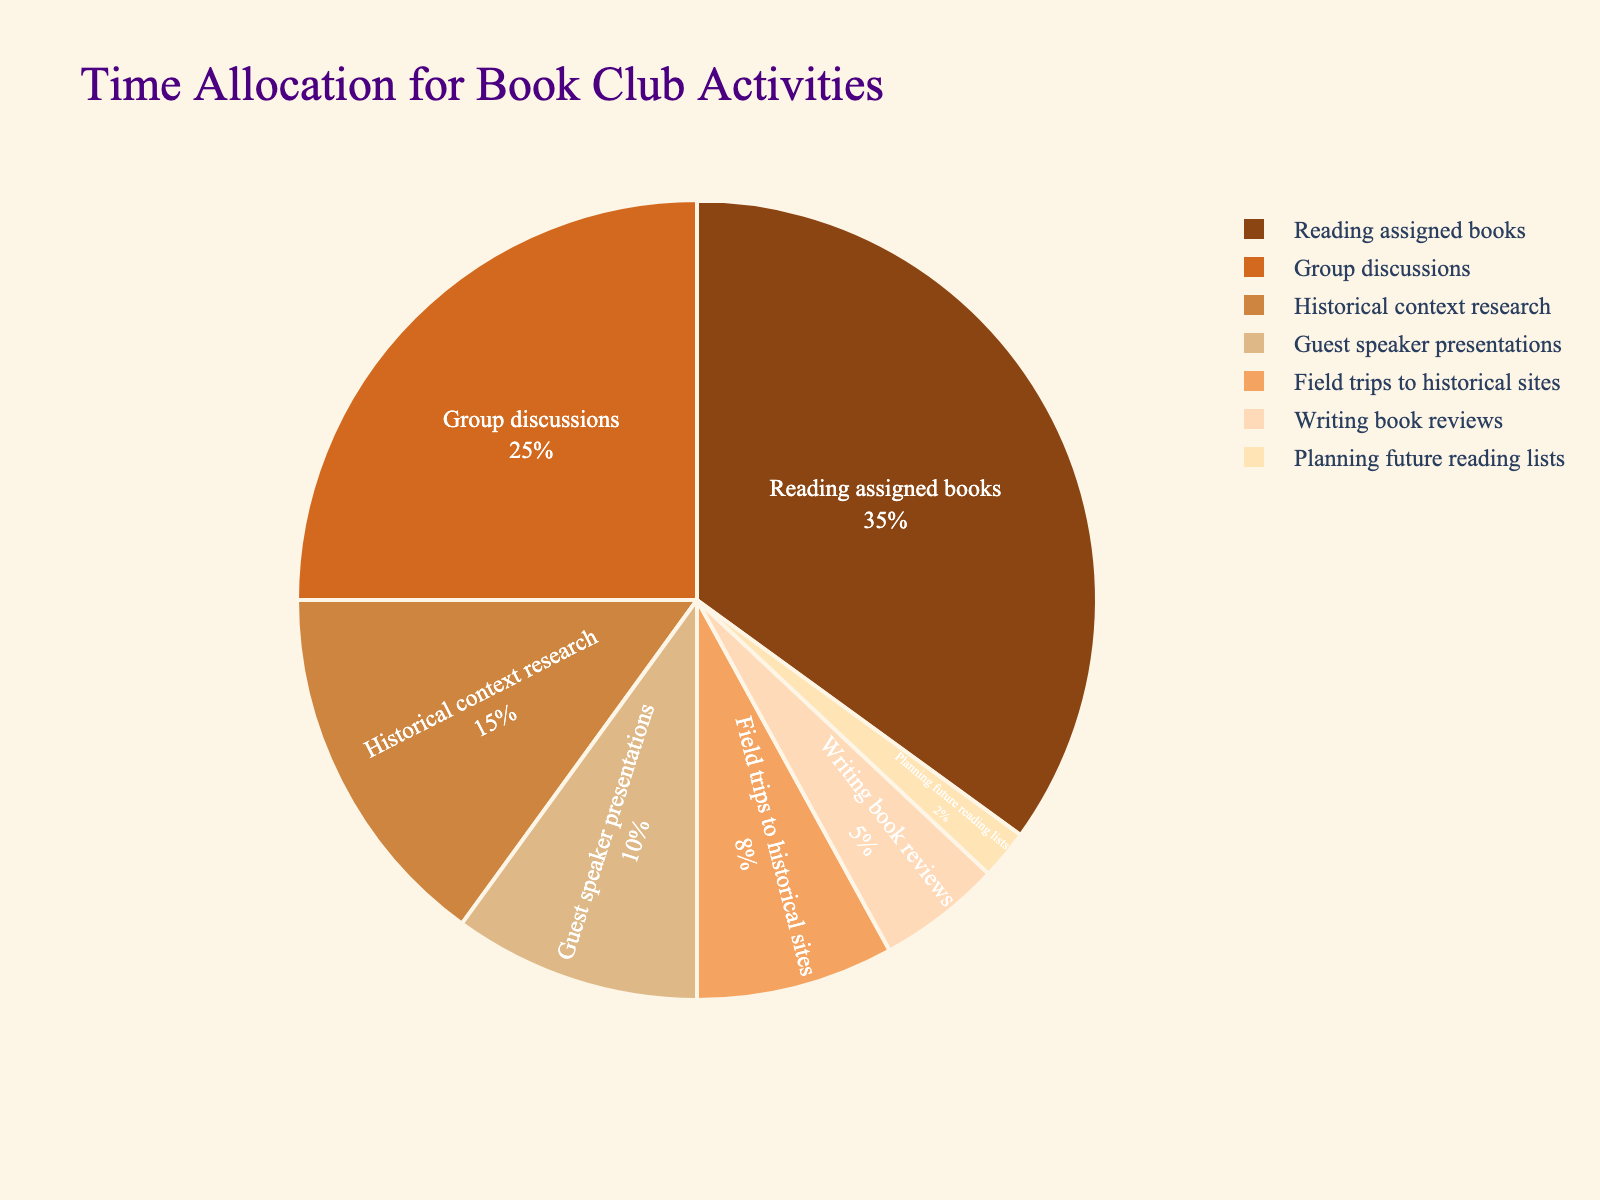What percentage of time is allocated to reading assigned books? Locate the segment for "Reading assigned books" and observe its label or corresponding percentage in the legend.
Answer: 35% How much more time is spent on group discussions compared to writing book reviews? Find the percentage values for "Group discussions" (25%) and "Writing book reviews" (5%), then subtract the latter from the former: 25% - 5%.
Answer: 20% Which activity has the smallest proportion of time allocated to it? Identify the segment with the smallest percentage value.
Answer: Planning future reading lists What are the two activities where the combined time spent is over 40%? Look for two segments whose percentages add up to more than 40%. "Reading assigned books" (35%) and "Group discussions" (25%) sum to 60%. Other combinations do not exceed 40%.
Answer: Reading assigned books and Group discussions How does the proportion of time spent on field trips to historical sites compare with that spent on writing book reviews? Check the percentage values for both activities: "Field trips to historical sites" (8%) and "Writing book reviews" (5%). Field trips have a higher percentage.
Answer: Field trips to historical sites have a higher proportion What's the total percentage of time spent on guest speaker presentations, field trips, and planning future reading lists combined? Add the percentages for "Guest speaker presentations" (10%), "Field trips to historical sites" (8%), and "Planning future reading lists" (2%): 10% + 8% + 2%.
Answer: 20% Which activities together make up exactly half of the book club's activities? Identify segments whose percentages sum up to 50%. "Historical context research" (15%) and "Group discussions" (25%) combined with "Planning future reading lists" (2%) equal 50%.
Answer: Historical context research and Group discussions and Planning future reading lists What is the average percentage of time spent on historical context research and guest speaker presentations? Average the percentages for "Historical context research" (15%) and "Guest speaker presentations" (10%). (15% + 10%) / 2 = 12.5%.
Answer: 12.5% How do the proportions of time spent on reading assigned books and planning future reading lists compare? Check the percentage values for both: "Reading assigned books" (35%) and "Planning future reading lists" (2%). Reading assigned books has a significantly higher percentage.
Answer: Reading assigned books has a higher proportion What percentage of time is spent on activities other than group discussions? Subtract the percentage of "Group discussions" from 100%: 100% - 25% = 75%.
Answer: 75% 